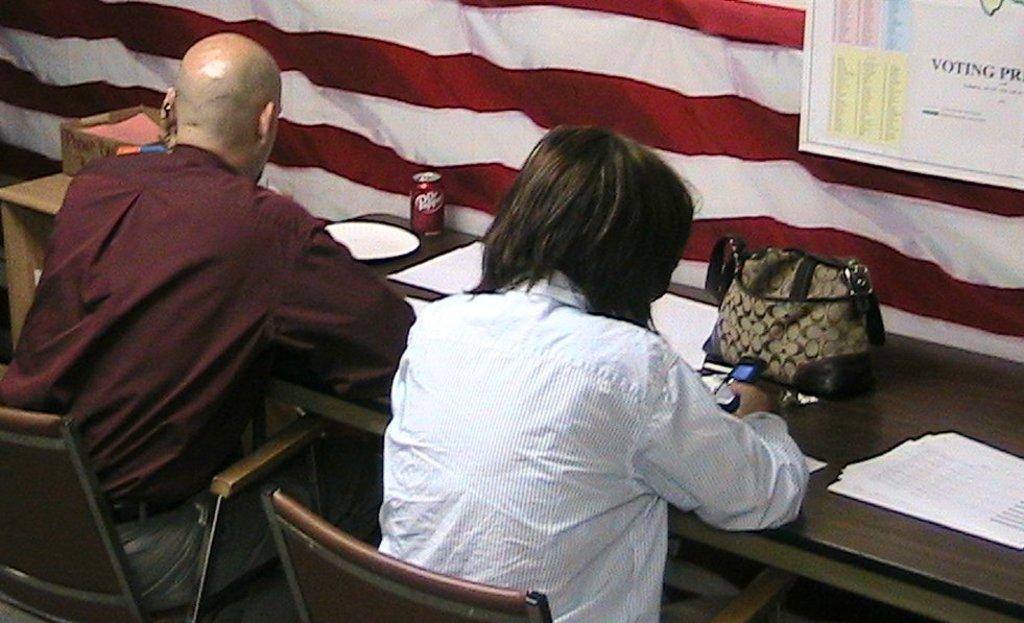Could you give a brief overview of what you see in this image? In this picture we can see two persons sitting on chairs in front of a table and on the table we can see papers, handbag,plate , box and a tin. We can see this person holding a mobile in his hand. This is a board. This is a white and red colour cloth. 